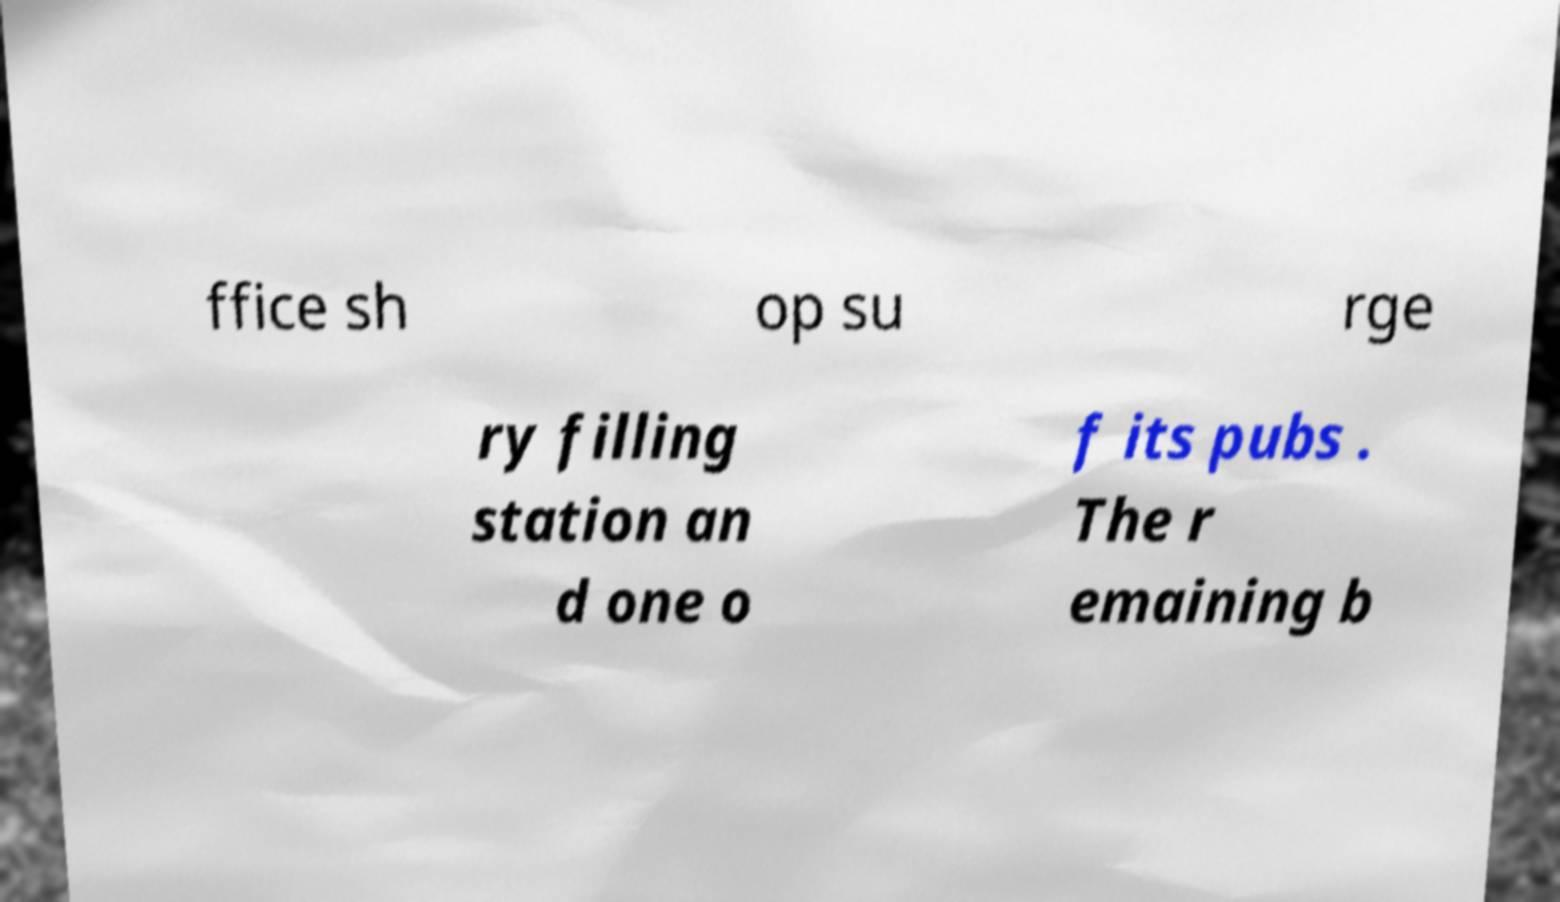Could you assist in decoding the text presented in this image and type it out clearly? ffice sh op su rge ry filling station an d one o f its pubs . The r emaining b 